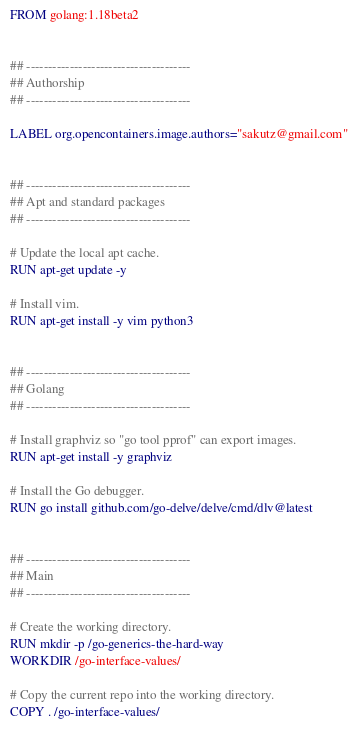<code> <loc_0><loc_0><loc_500><loc_500><_Dockerfile_>FROM golang:1.18beta2


## --------------------------------------
## Authorship
## --------------------------------------

LABEL org.opencontainers.image.authors="sakutz@gmail.com"


## --------------------------------------
## Apt and standard packages
## --------------------------------------

# Update the local apt cache.
RUN apt-get update -y

# Install vim.
RUN apt-get install -y vim python3


## --------------------------------------
## Golang
## --------------------------------------

# Install graphviz so "go tool pprof" can export images.
RUN apt-get install -y graphviz

# Install the Go debugger.
RUN go install github.com/go-delve/delve/cmd/dlv@latest


## --------------------------------------
## Main
## --------------------------------------

# Create the working directory.
RUN mkdir -p /go-generics-the-hard-way
WORKDIR /go-interface-values/

# Copy the current repo into the working directory.
COPY . /go-interface-values/
</code> 